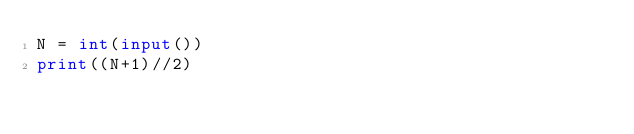Convert code to text. <code><loc_0><loc_0><loc_500><loc_500><_Python_>N = int(input())
print((N+1)//2)</code> 